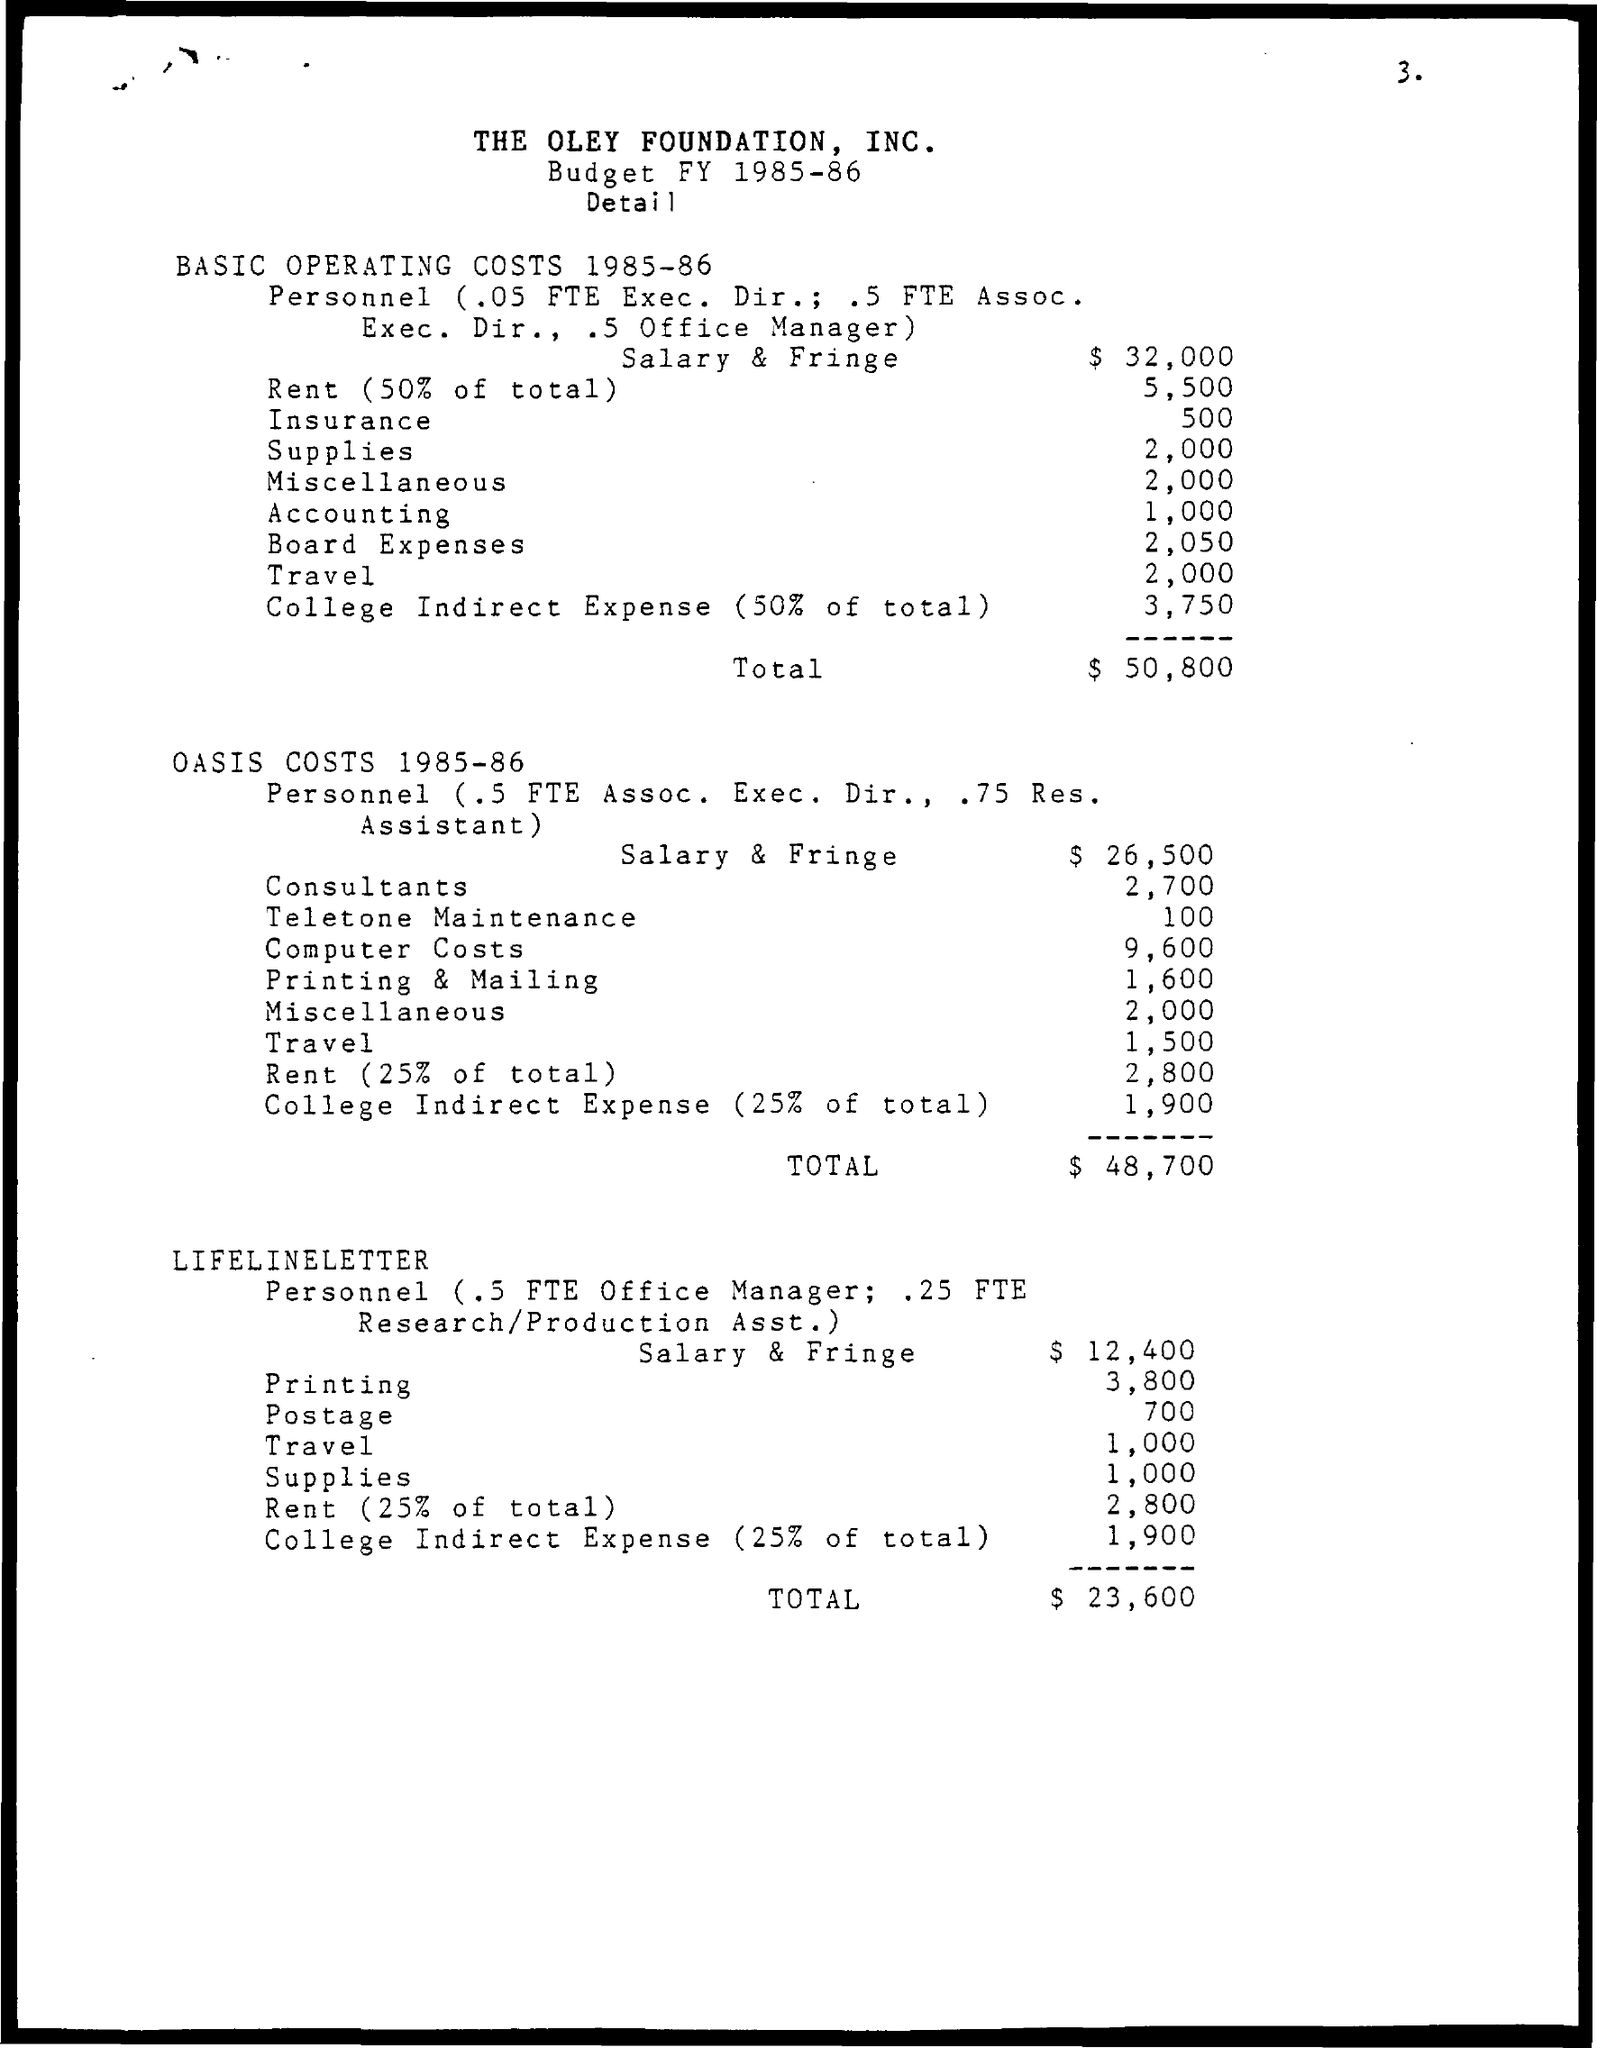What is the Insurance?
Your answer should be very brief. 500. What is the Expense for Accounting?
Ensure brevity in your answer.  1,000. What is the Board expenses?
Ensure brevity in your answer.  2,050. 